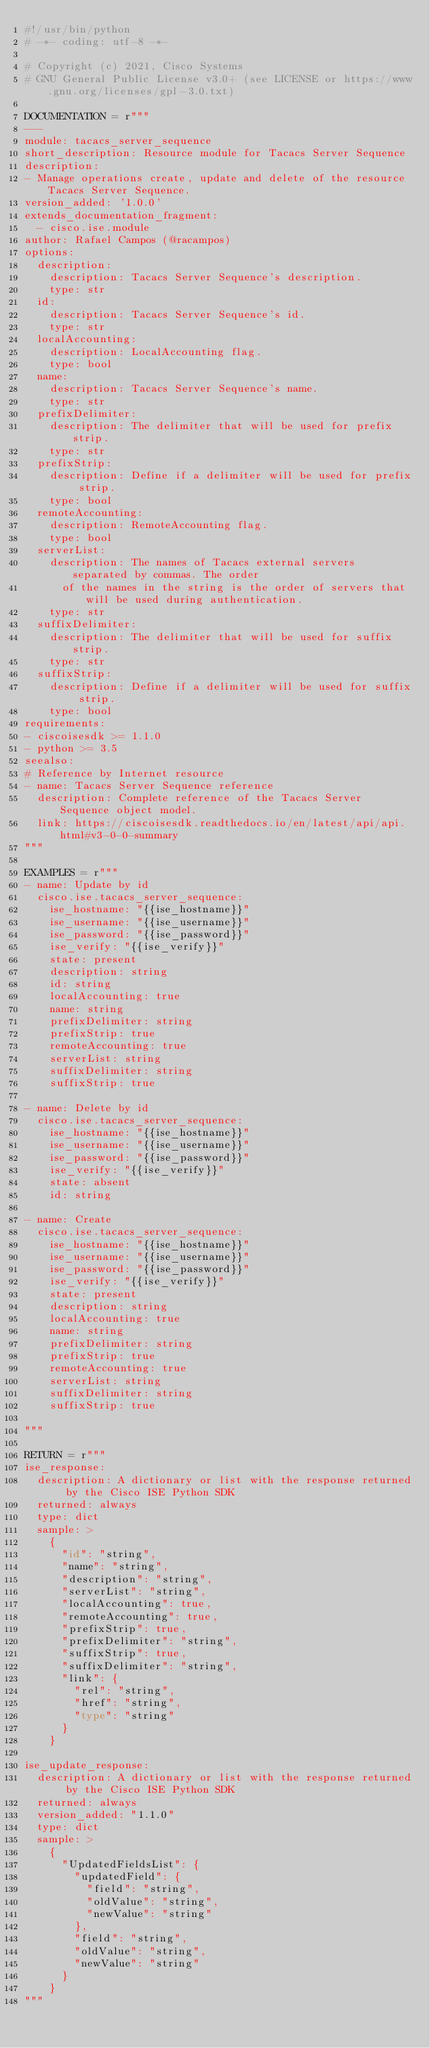Convert code to text. <code><loc_0><loc_0><loc_500><loc_500><_Python_>#!/usr/bin/python
# -*- coding: utf-8 -*-

# Copyright (c) 2021, Cisco Systems
# GNU General Public License v3.0+ (see LICENSE or https://www.gnu.org/licenses/gpl-3.0.txt)

DOCUMENTATION = r"""
---
module: tacacs_server_sequence
short_description: Resource module for Tacacs Server Sequence
description:
- Manage operations create, update and delete of the resource Tacacs Server Sequence.
version_added: '1.0.0'
extends_documentation_fragment:
  - cisco.ise.module
author: Rafael Campos (@racampos)
options:
  description:
    description: Tacacs Server Sequence's description.
    type: str
  id:
    description: Tacacs Server Sequence's id.
    type: str
  localAccounting:
    description: LocalAccounting flag.
    type: bool
  name:
    description: Tacacs Server Sequence's name.
    type: str
  prefixDelimiter:
    description: The delimiter that will be used for prefix strip.
    type: str
  prefixStrip:
    description: Define if a delimiter will be used for prefix strip.
    type: bool
  remoteAccounting:
    description: RemoteAccounting flag.
    type: bool
  serverList:
    description: The names of Tacacs external servers separated by commas. The order
      of the names in the string is the order of servers that will be used during authentication.
    type: str
  suffixDelimiter:
    description: The delimiter that will be used for suffix strip.
    type: str
  suffixStrip:
    description: Define if a delimiter will be used for suffix strip.
    type: bool
requirements:
- ciscoisesdk >= 1.1.0
- python >= 3.5
seealso:
# Reference by Internet resource
- name: Tacacs Server Sequence reference
  description: Complete reference of the Tacacs Server Sequence object model.
  link: https://ciscoisesdk.readthedocs.io/en/latest/api/api.html#v3-0-0-summary
"""

EXAMPLES = r"""
- name: Update by id
  cisco.ise.tacacs_server_sequence:
    ise_hostname: "{{ise_hostname}}"
    ise_username: "{{ise_username}}"
    ise_password: "{{ise_password}}"
    ise_verify: "{{ise_verify}}"
    state: present
    description: string
    id: string
    localAccounting: true
    name: string
    prefixDelimiter: string
    prefixStrip: true
    remoteAccounting: true
    serverList: string
    suffixDelimiter: string
    suffixStrip: true

- name: Delete by id
  cisco.ise.tacacs_server_sequence:
    ise_hostname: "{{ise_hostname}}"
    ise_username: "{{ise_username}}"
    ise_password: "{{ise_password}}"
    ise_verify: "{{ise_verify}}"
    state: absent
    id: string

- name: Create
  cisco.ise.tacacs_server_sequence:
    ise_hostname: "{{ise_hostname}}"
    ise_username: "{{ise_username}}"
    ise_password: "{{ise_password}}"
    ise_verify: "{{ise_verify}}"
    state: present
    description: string
    localAccounting: true
    name: string
    prefixDelimiter: string
    prefixStrip: true
    remoteAccounting: true
    serverList: string
    suffixDelimiter: string
    suffixStrip: true

"""

RETURN = r"""
ise_response:
  description: A dictionary or list with the response returned by the Cisco ISE Python SDK
  returned: always
  type: dict
  sample: >
    {
      "id": "string",
      "name": "string",
      "description": "string",
      "serverList": "string",
      "localAccounting": true,
      "remoteAccounting": true,
      "prefixStrip": true,
      "prefixDelimiter": "string",
      "suffixStrip": true,
      "suffixDelimiter": "string",
      "link": {
        "rel": "string",
        "href": "string",
        "type": "string"
      }
    }

ise_update_response:
  description: A dictionary or list with the response returned by the Cisco ISE Python SDK
  returned: always
  version_added: "1.1.0"
  type: dict
  sample: >
    {
      "UpdatedFieldsList": {
        "updatedField": {
          "field": "string",
          "oldValue": "string",
          "newValue": "string"
        },
        "field": "string",
        "oldValue": "string",
        "newValue": "string"
      }
    }
"""
</code> 